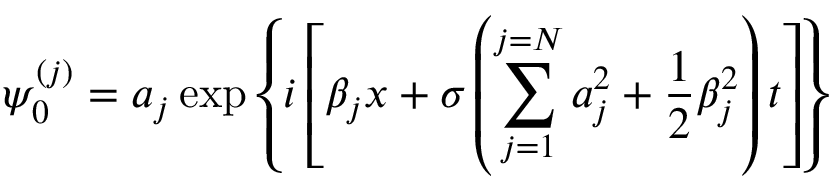<formula> <loc_0><loc_0><loc_500><loc_500>\psi _ { 0 } ^ { ( j ) } = a _ { j } \exp { \left \{ i \left [ \beta _ { j } x + \sigma \left ( \sum _ { j = 1 } ^ { j = N } a _ { j } ^ { 2 } + \frac { 1 } { 2 } \beta _ { j } ^ { 2 } \right ) t \right ] \right \} }</formula> 